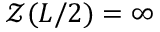Convert formula to latex. <formula><loc_0><loc_0><loc_500><loc_500>\mathcal { Z } ( L / 2 ) = \infty</formula> 